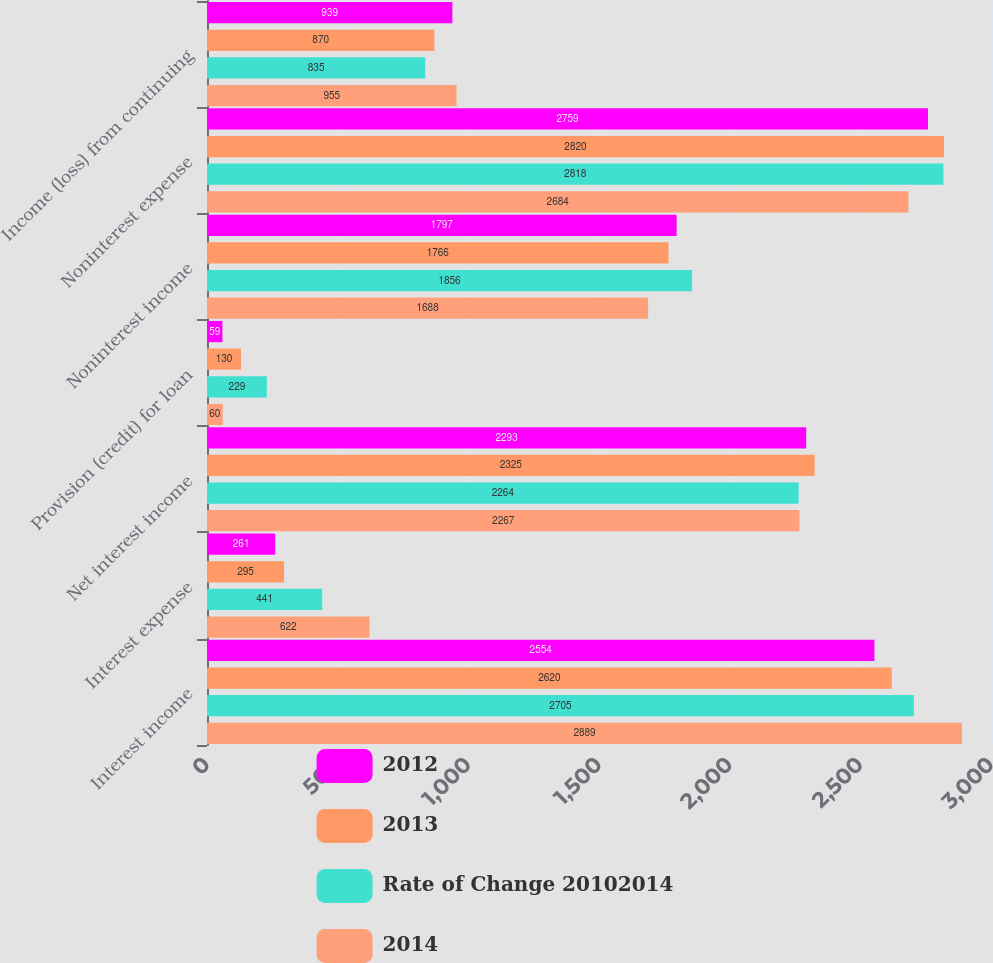Convert chart to OTSL. <chart><loc_0><loc_0><loc_500><loc_500><stacked_bar_chart><ecel><fcel>Interest income<fcel>Interest expense<fcel>Net interest income<fcel>Provision (credit) for loan<fcel>Noninterest income<fcel>Noninterest expense<fcel>Income (loss) from continuing<nl><fcel>2012<fcel>2554<fcel>261<fcel>2293<fcel>59<fcel>1797<fcel>2759<fcel>939<nl><fcel>2013<fcel>2620<fcel>295<fcel>2325<fcel>130<fcel>1766<fcel>2820<fcel>870<nl><fcel>Rate of Change 20102014<fcel>2705<fcel>441<fcel>2264<fcel>229<fcel>1856<fcel>2818<fcel>835<nl><fcel>2014<fcel>2889<fcel>622<fcel>2267<fcel>60<fcel>1688<fcel>2684<fcel>955<nl></chart> 